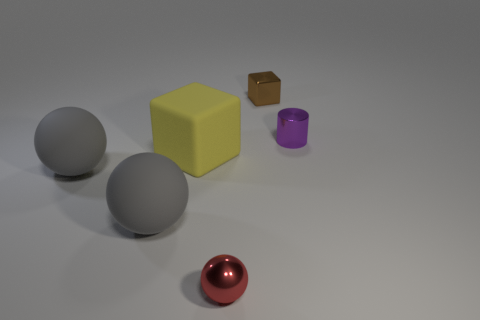What is the material of the yellow block?
Give a very brief answer. Rubber. Does the brown metallic thing have the same shape as the yellow object?
Keep it short and to the point. Yes. Is there a tiny blue block that has the same material as the red sphere?
Provide a succinct answer. No. What color is the thing that is on the right side of the large yellow matte cube and to the left of the metallic block?
Ensure brevity in your answer.  Red. What material is the block right of the matte cube?
Your answer should be very brief. Metal. Are there any other tiny rubber things that have the same shape as the small purple thing?
Give a very brief answer. No. What number of other things are there of the same shape as the small purple object?
Offer a very short reply. 0. Is the shape of the large yellow matte thing the same as the red object that is to the left of the tiny cube?
Ensure brevity in your answer.  No. Is there anything else that is the same material as the small purple cylinder?
Make the answer very short. Yes. There is a small thing that is the same shape as the large yellow object; what is its material?
Provide a succinct answer. Metal. 